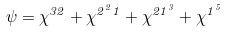Convert formula to latex. <formula><loc_0><loc_0><loc_500><loc_500>\psi = \chi ^ { 3 2 } + \chi ^ { 2 ^ { 2 } 1 } + \chi ^ { 2 1 ^ { 3 } } + \chi ^ { 1 ^ { 5 } }</formula> 